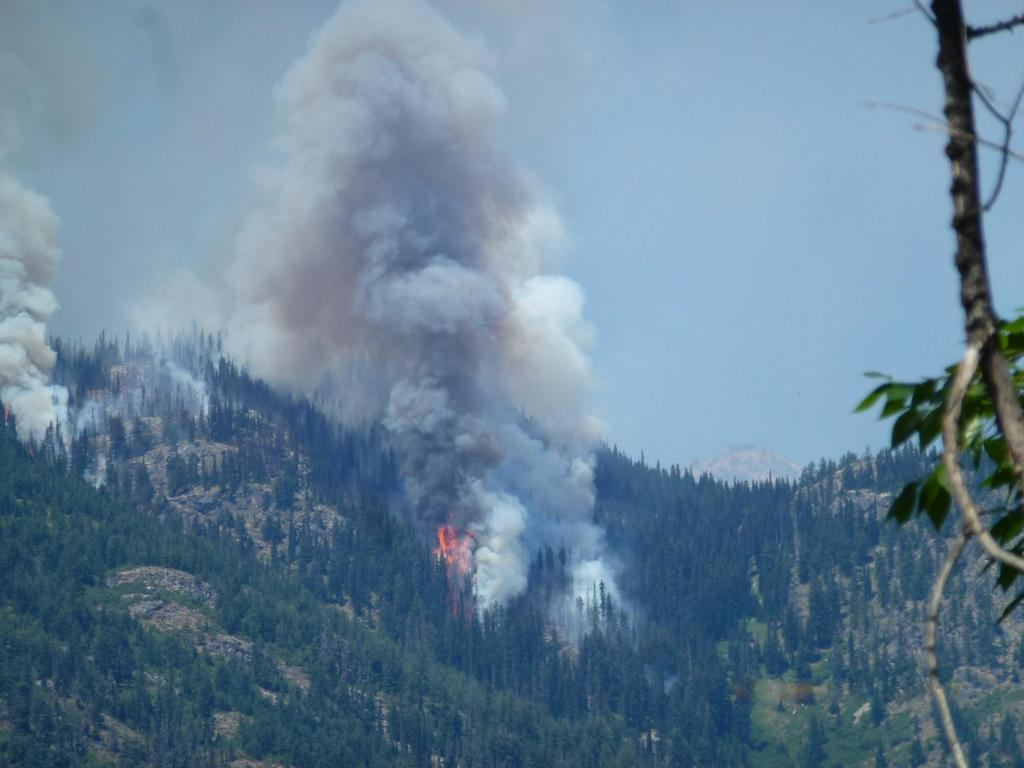What type of vegetation can be seen in the image? There are trees in the image. What is happening in the image that involves heat or combustion? There is fire in the image. What is a result of the fire in the image? There is smoke in the image. What can be seen in the distance in the image? The sky is visible in the background of the image. How many women are flying kites in the image? There are no women or kites present in the image. What type of powder is being used to create the fire in the image? There is no powder present in the image, and the fire is not explained in the provided facts. 